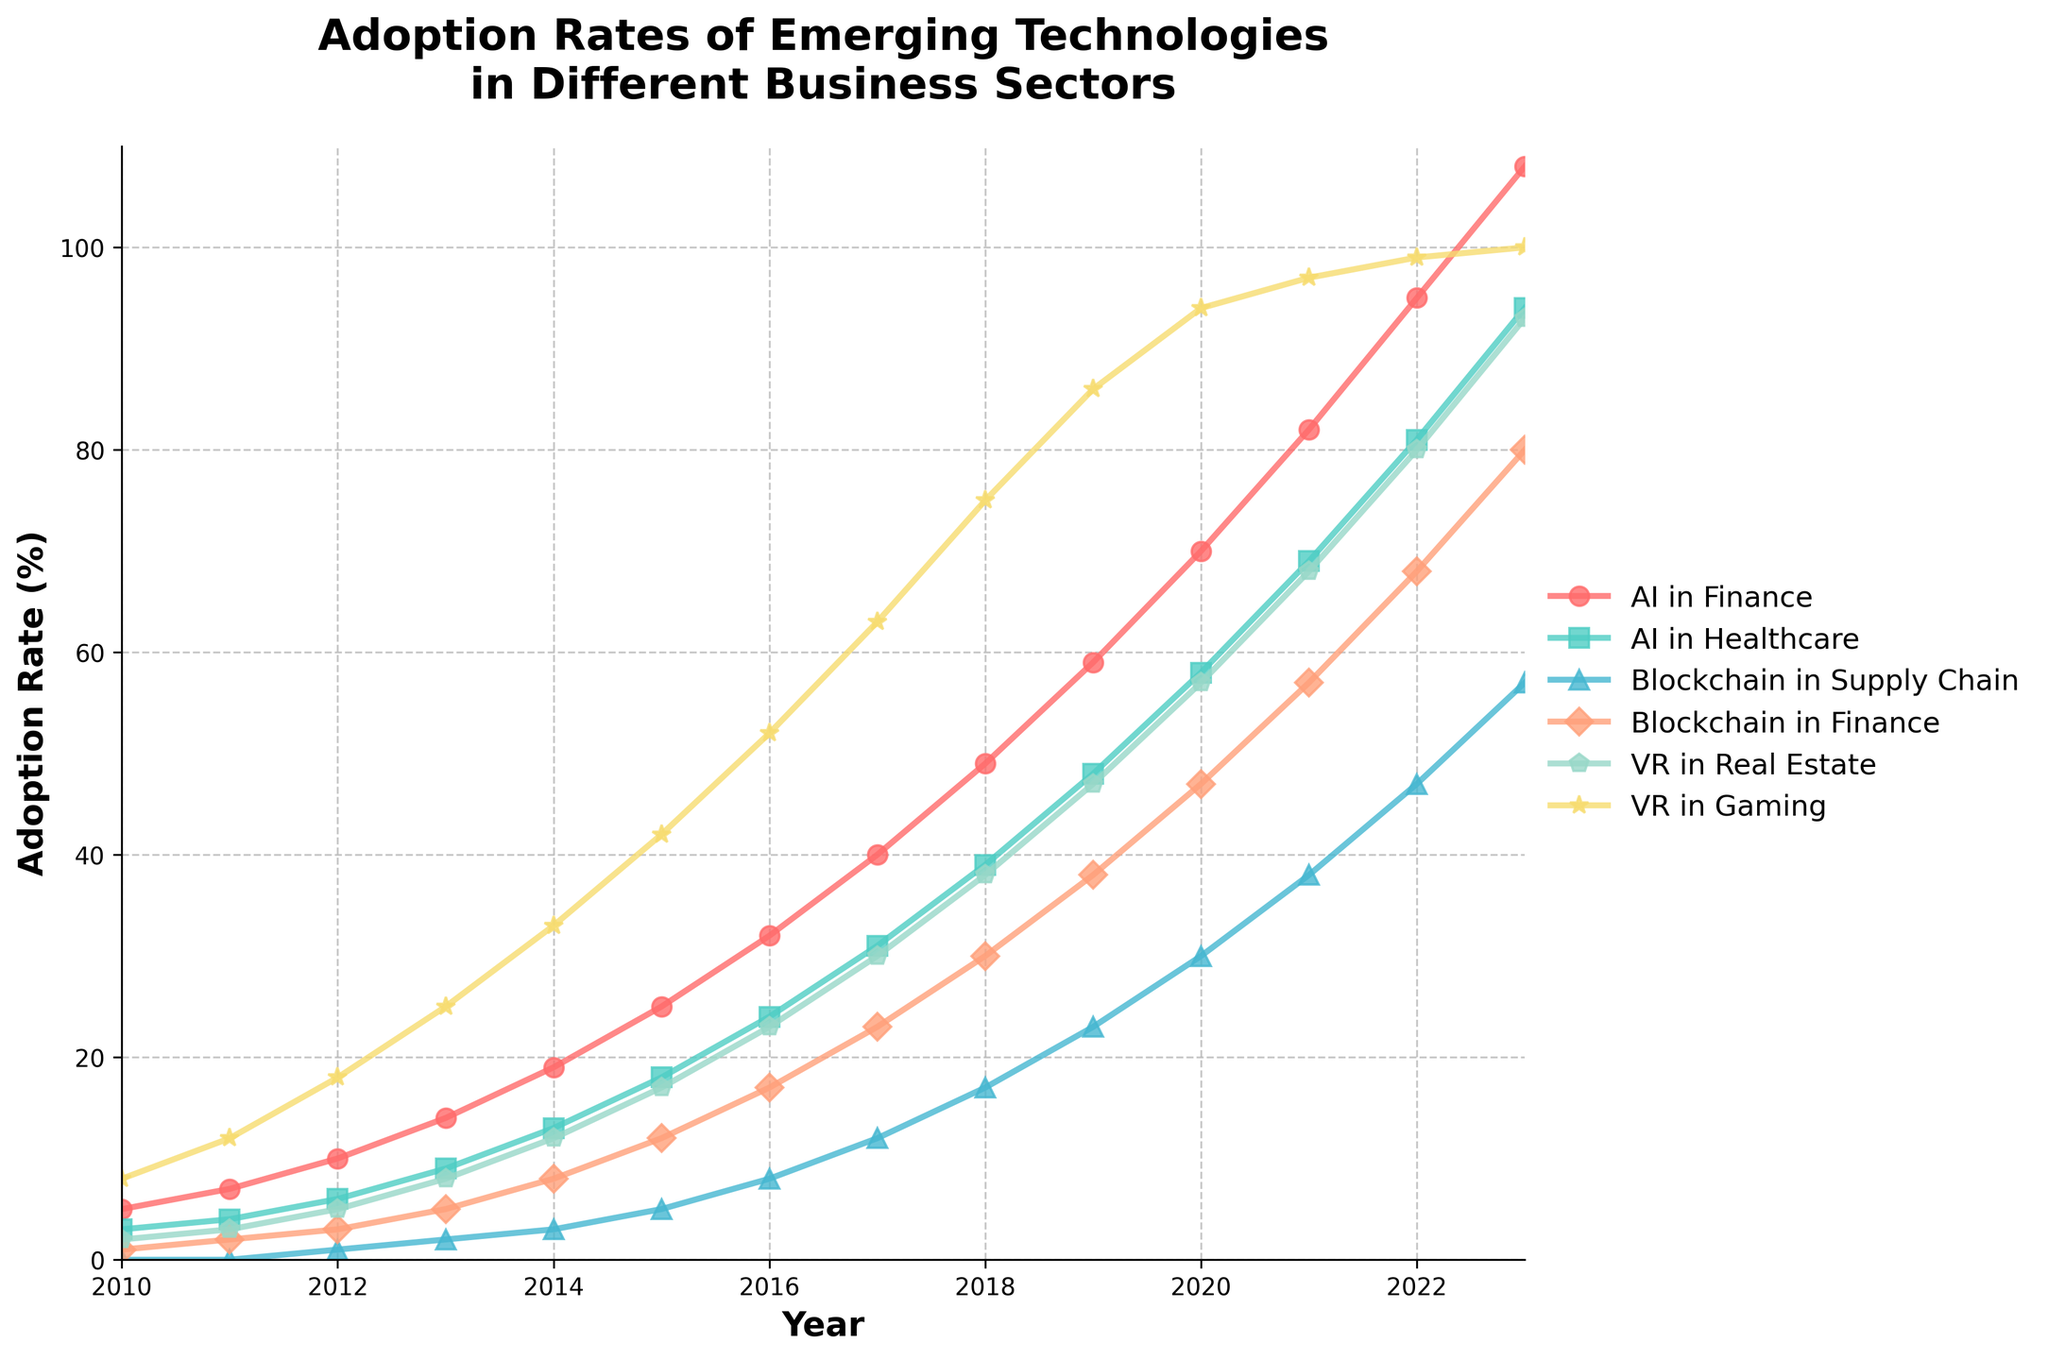What is the adoption rate of AI in Healthcare in 2020? To find the adoption rate of AI in Healthcare in 2020, locate the corresponding point on the 'AI in Healthcare' line for the year 2020.
Answer: 58% Which sector had the highest adoption rate in 2018? To determine this, compare the adoption rates of all the sectors for the year 2018. The 'VR in Gaming' line peaks the highest in 2018.
Answer: VR in Gaming How much did the adoption rate of Blockchain in Finance increase from 2015 to 2019? Find the adoption rates for Blockchain in Finance in the years 2015 and 2019, then subtract the earlier value from the later value (38 - 12 = 26).
Answer: 26% Which technology in finance had a higher adoption rate in 2017, AI or Blockchain? Compare the adoption rates for AI in Finance and Blockchain in Finance for the year 2017. AI in Finance has a higher value at 40% compared to Blockchain in Finance at 23%.
Answer: AI in Finance What is the average adoption rate of VR in Real Estate from 2010 to 2015? Sum the adoption rates of VR in Real Estate from 2010 to 2015 ((2 + 3 + 5 + 8 + 12 + 17) = 47), then divide by the number of years (47 / 6).
Answer: 7.83% Which technology had the slowest adoption growth from 2010 to 2012? Compare the increase in adoption rates of all technologies from 2010 to 2012; 'Blockchain in Supply Chain' had the slowest growth, rising from 0% to 1% (an increase of 1%).
Answer: Blockchain in Supply Chain In which year did the adoption rate of AI in Finance surpass 50%? Determine the year when the adoption rate of AI in Finance first exceeds 50%; it’s in 2018 when it reaches 49%, and in 2019 it is above 50%. So it first surpasses 50% in 2019.
Answer: 2019 What is the difference in adoption rates between VR in Gaming and AI in Healthcare in 2023? Find the adoption rates of VR in Gaming and AI in Healthcare in 2023, then subtract the latter from the former (100 - 94).
Answer: 6% Identify two technologies whose adoption rates were equal in 2021. Look for adoption rates that coincide in the year 2021. Both 'VR in Gaming' and 'Blockchain in Finance' have an adoption rate of 97% in 2021.
Answer: VR in Gaming, Blockchain in Finance What is the sum of adoption rates for all sectors in the year 2023? Add the adoption rates for all the sectors in 2023 (108 + 94 + 57 + 80 + 93 + 100 = 532).
Answer: 532 